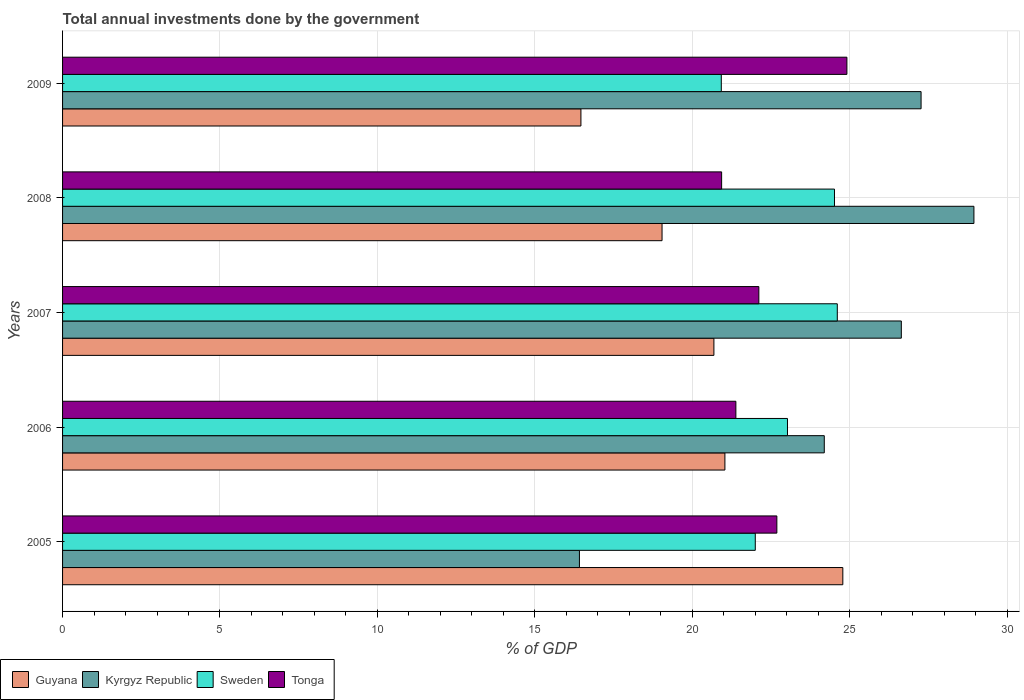How many different coloured bars are there?
Give a very brief answer. 4. Are the number of bars per tick equal to the number of legend labels?
Ensure brevity in your answer.  Yes. How many bars are there on the 5th tick from the top?
Your response must be concise. 4. How many bars are there on the 4th tick from the bottom?
Ensure brevity in your answer.  4. In how many cases, is the number of bars for a given year not equal to the number of legend labels?
Make the answer very short. 0. What is the total annual investments done by the government in Tonga in 2008?
Offer a terse response. 20.93. Across all years, what is the maximum total annual investments done by the government in Sweden?
Provide a short and direct response. 24.61. Across all years, what is the minimum total annual investments done by the government in Guyana?
Offer a very short reply. 16.47. In which year was the total annual investments done by the government in Guyana minimum?
Offer a terse response. 2009. What is the total total annual investments done by the government in Kyrgyz Republic in the graph?
Provide a short and direct response. 123.48. What is the difference between the total annual investments done by the government in Kyrgyz Republic in 2005 and that in 2008?
Make the answer very short. -12.53. What is the difference between the total annual investments done by the government in Guyana in 2009 and the total annual investments done by the government in Sweden in 2007?
Give a very brief answer. -8.14. What is the average total annual investments done by the government in Guyana per year?
Offer a terse response. 20.4. In the year 2005, what is the difference between the total annual investments done by the government in Tonga and total annual investments done by the government in Sweden?
Your answer should be compact. 0.69. In how many years, is the total annual investments done by the government in Tonga greater than 10 %?
Your response must be concise. 5. What is the ratio of the total annual investments done by the government in Kyrgyz Republic in 2007 to that in 2008?
Offer a terse response. 0.92. Is the difference between the total annual investments done by the government in Tonga in 2005 and 2006 greater than the difference between the total annual investments done by the government in Sweden in 2005 and 2006?
Keep it short and to the point. Yes. What is the difference between the highest and the second highest total annual investments done by the government in Tonga?
Your answer should be compact. 2.23. What is the difference between the highest and the lowest total annual investments done by the government in Guyana?
Make the answer very short. 8.32. Is the sum of the total annual investments done by the government in Sweden in 2005 and 2007 greater than the maximum total annual investments done by the government in Guyana across all years?
Give a very brief answer. Yes. Is it the case that in every year, the sum of the total annual investments done by the government in Guyana and total annual investments done by the government in Tonga is greater than the sum of total annual investments done by the government in Kyrgyz Republic and total annual investments done by the government in Sweden?
Make the answer very short. No. What does the 1st bar from the top in 2007 represents?
Ensure brevity in your answer.  Tonga. Is it the case that in every year, the sum of the total annual investments done by the government in Guyana and total annual investments done by the government in Kyrgyz Republic is greater than the total annual investments done by the government in Tonga?
Your answer should be compact. Yes. Are all the bars in the graph horizontal?
Offer a very short reply. Yes. How many years are there in the graph?
Provide a succinct answer. 5. Does the graph contain any zero values?
Provide a short and direct response. No. Where does the legend appear in the graph?
Ensure brevity in your answer.  Bottom left. How many legend labels are there?
Your answer should be very brief. 4. How are the legend labels stacked?
Give a very brief answer. Horizontal. What is the title of the graph?
Make the answer very short. Total annual investments done by the government. Does "Latin America(developing only)" appear as one of the legend labels in the graph?
Make the answer very short. No. What is the label or title of the X-axis?
Ensure brevity in your answer.  % of GDP. What is the label or title of the Y-axis?
Your response must be concise. Years. What is the % of GDP in Guyana in 2005?
Offer a very short reply. 24.78. What is the % of GDP of Kyrgyz Republic in 2005?
Give a very brief answer. 16.42. What is the % of GDP in Sweden in 2005?
Give a very brief answer. 22. What is the % of GDP in Tonga in 2005?
Keep it short and to the point. 22.69. What is the % of GDP of Guyana in 2006?
Your answer should be compact. 21.04. What is the % of GDP in Kyrgyz Republic in 2006?
Your answer should be very brief. 24.2. What is the % of GDP in Sweden in 2006?
Make the answer very short. 23.03. What is the % of GDP of Tonga in 2006?
Keep it short and to the point. 21.39. What is the % of GDP in Guyana in 2007?
Give a very brief answer. 20.69. What is the % of GDP of Kyrgyz Republic in 2007?
Offer a very short reply. 26.64. What is the % of GDP in Sweden in 2007?
Your response must be concise. 24.61. What is the % of GDP of Tonga in 2007?
Your answer should be compact. 22.12. What is the % of GDP in Guyana in 2008?
Ensure brevity in your answer.  19.04. What is the % of GDP of Kyrgyz Republic in 2008?
Provide a succinct answer. 28.95. What is the % of GDP of Sweden in 2008?
Make the answer very short. 24.52. What is the % of GDP in Tonga in 2008?
Your answer should be compact. 20.93. What is the % of GDP in Guyana in 2009?
Your answer should be very brief. 16.47. What is the % of GDP of Kyrgyz Republic in 2009?
Give a very brief answer. 27.27. What is the % of GDP in Sweden in 2009?
Offer a very short reply. 20.92. What is the % of GDP in Tonga in 2009?
Offer a very short reply. 24.91. Across all years, what is the maximum % of GDP in Guyana?
Provide a succinct answer. 24.78. Across all years, what is the maximum % of GDP in Kyrgyz Republic?
Give a very brief answer. 28.95. Across all years, what is the maximum % of GDP of Sweden?
Your answer should be very brief. 24.61. Across all years, what is the maximum % of GDP in Tonga?
Keep it short and to the point. 24.91. Across all years, what is the minimum % of GDP in Guyana?
Ensure brevity in your answer.  16.47. Across all years, what is the minimum % of GDP in Kyrgyz Republic?
Offer a very short reply. 16.42. Across all years, what is the minimum % of GDP in Sweden?
Keep it short and to the point. 20.92. Across all years, what is the minimum % of GDP in Tonga?
Give a very brief answer. 20.93. What is the total % of GDP in Guyana in the graph?
Provide a succinct answer. 102.02. What is the total % of GDP in Kyrgyz Republic in the graph?
Keep it short and to the point. 123.48. What is the total % of GDP in Sweden in the graph?
Your answer should be very brief. 115.08. What is the total % of GDP in Tonga in the graph?
Provide a succinct answer. 112.04. What is the difference between the % of GDP of Guyana in 2005 and that in 2006?
Give a very brief answer. 3.75. What is the difference between the % of GDP of Kyrgyz Republic in 2005 and that in 2006?
Provide a succinct answer. -7.78. What is the difference between the % of GDP in Sweden in 2005 and that in 2006?
Provide a succinct answer. -1.02. What is the difference between the % of GDP of Tonga in 2005 and that in 2006?
Provide a short and direct response. 1.3. What is the difference between the % of GDP of Guyana in 2005 and that in 2007?
Your answer should be very brief. 4.1. What is the difference between the % of GDP in Kyrgyz Republic in 2005 and that in 2007?
Offer a terse response. -10.22. What is the difference between the % of GDP of Sweden in 2005 and that in 2007?
Offer a terse response. -2.6. What is the difference between the % of GDP of Tonga in 2005 and that in 2007?
Keep it short and to the point. 0.57. What is the difference between the % of GDP of Guyana in 2005 and that in 2008?
Your answer should be compact. 5.74. What is the difference between the % of GDP in Kyrgyz Republic in 2005 and that in 2008?
Make the answer very short. -12.53. What is the difference between the % of GDP of Sweden in 2005 and that in 2008?
Keep it short and to the point. -2.52. What is the difference between the % of GDP of Tonga in 2005 and that in 2008?
Your answer should be compact. 1.75. What is the difference between the % of GDP in Guyana in 2005 and that in 2009?
Provide a short and direct response. 8.32. What is the difference between the % of GDP of Kyrgyz Republic in 2005 and that in 2009?
Provide a short and direct response. -10.85. What is the difference between the % of GDP in Sweden in 2005 and that in 2009?
Ensure brevity in your answer.  1.08. What is the difference between the % of GDP in Tonga in 2005 and that in 2009?
Keep it short and to the point. -2.23. What is the difference between the % of GDP in Guyana in 2006 and that in 2007?
Offer a terse response. 0.35. What is the difference between the % of GDP in Kyrgyz Republic in 2006 and that in 2007?
Keep it short and to the point. -2.45. What is the difference between the % of GDP of Sweden in 2006 and that in 2007?
Make the answer very short. -1.58. What is the difference between the % of GDP in Tonga in 2006 and that in 2007?
Your answer should be compact. -0.73. What is the difference between the % of GDP in Guyana in 2006 and that in 2008?
Provide a short and direct response. 2. What is the difference between the % of GDP of Kyrgyz Republic in 2006 and that in 2008?
Give a very brief answer. -4.75. What is the difference between the % of GDP of Sweden in 2006 and that in 2008?
Your answer should be compact. -1.49. What is the difference between the % of GDP of Tonga in 2006 and that in 2008?
Ensure brevity in your answer.  0.45. What is the difference between the % of GDP of Guyana in 2006 and that in 2009?
Provide a succinct answer. 4.57. What is the difference between the % of GDP in Kyrgyz Republic in 2006 and that in 2009?
Offer a very short reply. -3.07. What is the difference between the % of GDP of Sweden in 2006 and that in 2009?
Your response must be concise. 2.1. What is the difference between the % of GDP in Tonga in 2006 and that in 2009?
Keep it short and to the point. -3.53. What is the difference between the % of GDP in Guyana in 2007 and that in 2008?
Provide a short and direct response. 1.65. What is the difference between the % of GDP of Kyrgyz Republic in 2007 and that in 2008?
Ensure brevity in your answer.  -2.31. What is the difference between the % of GDP of Sweden in 2007 and that in 2008?
Give a very brief answer. 0.09. What is the difference between the % of GDP of Tonga in 2007 and that in 2008?
Ensure brevity in your answer.  1.18. What is the difference between the % of GDP of Guyana in 2007 and that in 2009?
Offer a very short reply. 4.22. What is the difference between the % of GDP in Kyrgyz Republic in 2007 and that in 2009?
Make the answer very short. -0.63. What is the difference between the % of GDP in Sweden in 2007 and that in 2009?
Your answer should be very brief. 3.68. What is the difference between the % of GDP in Tonga in 2007 and that in 2009?
Make the answer very short. -2.8. What is the difference between the % of GDP of Guyana in 2008 and that in 2009?
Offer a terse response. 2.58. What is the difference between the % of GDP in Kyrgyz Republic in 2008 and that in 2009?
Keep it short and to the point. 1.68. What is the difference between the % of GDP of Sweden in 2008 and that in 2009?
Make the answer very short. 3.6. What is the difference between the % of GDP of Tonga in 2008 and that in 2009?
Provide a short and direct response. -3.98. What is the difference between the % of GDP of Guyana in 2005 and the % of GDP of Kyrgyz Republic in 2006?
Ensure brevity in your answer.  0.59. What is the difference between the % of GDP in Guyana in 2005 and the % of GDP in Sweden in 2006?
Your answer should be very brief. 1.76. What is the difference between the % of GDP in Guyana in 2005 and the % of GDP in Tonga in 2006?
Offer a terse response. 3.4. What is the difference between the % of GDP in Kyrgyz Republic in 2005 and the % of GDP in Sweden in 2006?
Offer a terse response. -6.61. What is the difference between the % of GDP in Kyrgyz Republic in 2005 and the % of GDP in Tonga in 2006?
Your answer should be very brief. -4.97. What is the difference between the % of GDP of Sweden in 2005 and the % of GDP of Tonga in 2006?
Your answer should be compact. 0.62. What is the difference between the % of GDP of Guyana in 2005 and the % of GDP of Kyrgyz Republic in 2007?
Your answer should be compact. -1.86. What is the difference between the % of GDP of Guyana in 2005 and the % of GDP of Sweden in 2007?
Offer a very short reply. 0.18. What is the difference between the % of GDP in Guyana in 2005 and the % of GDP in Tonga in 2007?
Provide a short and direct response. 2.67. What is the difference between the % of GDP of Kyrgyz Republic in 2005 and the % of GDP of Sweden in 2007?
Offer a very short reply. -8.19. What is the difference between the % of GDP in Kyrgyz Republic in 2005 and the % of GDP in Tonga in 2007?
Your answer should be compact. -5.7. What is the difference between the % of GDP of Sweden in 2005 and the % of GDP of Tonga in 2007?
Keep it short and to the point. -0.11. What is the difference between the % of GDP of Guyana in 2005 and the % of GDP of Kyrgyz Republic in 2008?
Your response must be concise. -4.16. What is the difference between the % of GDP of Guyana in 2005 and the % of GDP of Sweden in 2008?
Offer a very short reply. 0.27. What is the difference between the % of GDP of Guyana in 2005 and the % of GDP of Tonga in 2008?
Your answer should be compact. 3.85. What is the difference between the % of GDP of Kyrgyz Republic in 2005 and the % of GDP of Sweden in 2008?
Make the answer very short. -8.1. What is the difference between the % of GDP in Kyrgyz Republic in 2005 and the % of GDP in Tonga in 2008?
Ensure brevity in your answer.  -4.52. What is the difference between the % of GDP in Sweden in 2005 and the % of GDP in Tonga in 2008?
Provide a succinct answer. 1.07. What is the difference between the % of GDP of Guyana in 2005 and the % of GDP of Kyrgyz Republic in 2009?
Your response must be concise. -2.49. What is the difference between the % of GDP of Guyana in 2005 and the % of GDP of Sweden in 2009?
Offer a very short reply. 3.86. What is the difference between the % of GDP in Guyana in 2005 and the % of GDP in Tonga in 2009?
Make the answer very short. -0.13. What is the difference between the % of GDP in Kyrgyz Republic in 2005 and the % of GDP in Sweden in 2009?
Ensure brevity in your answer.  -4.51. What is the difference between the % of GDP of Kyrgyz Republic in 2005 and the % of GDP of Tonga in 2009?
Provide a succinct answer. -8.5. What is the difference between the % of GDP in Sweden in 2005 and the % of GDP in Tonga in 2009?
Ensure brevity in your answer.  -2.91. What is the difference between the % of GDP in Guyana in 2006 and the % of GDP in Kyrgyz Republic in 2007?
Your answer should be very brief. -5.6. What is the difference between the % of GDP in Guyana in 2006 and the % of GDP in Sweden in 2007?
Your answer should be very brief. -3.57. What is the difference between the % of GDP of Guyana in 2006 and the % of GDP of Tonga in 2007?
Ensure brevity in your answer.  -1.08. What is the difference between the % of GDP of Kyrgyz Republic in 2006 and the % of GDP of Sweden in 2007?
Provide a short and direct response. -0.41. What is the difference between the % of GDP of Kyrgyz Republic in 2006 and the % of GDP of Tonga in 2007?
Ensure brevity in your answer.  2.08. What is the difference between the % of GDP in Sweden in 2006 and the % of GDP in Tonga in 2007?
Ensure brevity in your answer.  0.91. What is the difference between the % of GDP in Guyana in 2006 and the % of GDP in Kyrgyz Republic in 2008?
Ensure brevity in your answer.  -7.91. What is the difference between the % of GDP in Guyana in 2006 and the % of GDP in Sweden in 2008?
Provide a short and direct response. -3.48. What is the difference between the % of GDP of Guyana in 2006 and the % of GDP of Tonga in 2008?
Your response must be concise. 0.1. What is the difference between the % of GDP in Kyrgyz Republic in 2006 and the % of GDP in Sweden in 2008?
Keep it short and to the point. -0.32. What is the difference between the % of GDP of Kyrgyz Republic in 2006 and the % of GDP of Tonga in 2008?
Provide a short and direct response. 3.26. What is the difference between the % of GDP of Sweden in 2006 and the % of GDP of Tonga in 2008?
Offer a terse response. 2.09. What is the difference between the % of GDP of Guyana in 2006 and the % of GDP of Kyrgyz Republic in 2009?
Keep it short and to the point. -6.23. What is the difference between the % of GDP of Guyana in 2006 and the % of GDP of Sweden in 2009?
Offer a terse response. 0.12. What is the difference between the % of GDP in Guyana in 2006 and the % of GDP in Tonga in 2009?
Your answer should be compact. -3.87. What is the difference between the % of GDP of Kyrgyz Republic in 2006 and the % of GDP of Sweden in 2009?
Ensure brevity in your answer.  3.27. What is the difference between the % of GDP of Kyrgyz Republic in 2006 and the % of GDP of Tonga in 2009?
Provide a succinct answer. -0.72. What is the difference between the % of GDP of Sweden in 2006 and the % of GDP of Tonga in 2009?
Keep it short and to the point. -1.89. What is the difference between the % of GDP in Guyana in 2007 and the % of GDP in Kyrgyz Republic in 2008?
Your response must be concise. -8.26. What is the difference between the % of GDP of Guyana in 2007 and the % of GDP of Sweden in 2008?
Keep it short and to the point. -3.83. What is the difference between the % of GDP of Guyana in 2007 and the % of GDP of Tonga in 2008?
Your answer should be compact. -0.24. What is the difference between the % of GDP in Kyrgyz Republic in 2007 and the % of GDP in Sweden in 2008?
Provide a short and direct response. 2.12. What is the difference between the % of GDP in Kyrgyz Republic in 2007 and the % of GDP in Tonga in 2008?
Provide a short and direct response. 5.71. What is the difference between the % of GDP of Sweden in 2007 and the % of GDP of Tonga in 2008?
Your answer should be compact. 3.67. What is the difference between the % of GDP of Guyana in 2007 and the % of GDP of Kyrgyz Republic in 2009?
Provide a succinct answer. -6.58. What is the difference between the % of GDP of Guyana in 2007 and the % of GDP of Sweden in 2009?
Ensure brevity in your answer.  -0.23. What is the difference between the % of GDP of Guyana in 2007 and the % of GDP of Tonga in 2009?
Ensure brevity in your answer.  -4.22. What is the difference between the % of GDP in Kyrgyz Republic in 2007 and the % of GDP in Sweden in 2009?
Give a very brief answer. 5.72. What is the difference between the % of GDP in Kyrgyz Republic in 2007 and the % of GDP in Tonga in 2009?
Your response must be concise. 1.73. What is the difference between the % of GDP of Sweden in 2007 and the % of GDP of Tonga in 2009?
Your answer should be compact. -0.31. What is the difference between the % of GDP of Guyana in 2008 and the % of GDP of Kyrgyz Republic in 2009?
Make the answer very short. -8.23. What is the difference between the % of GDP in Guyana in 2008 and the % of GDP in Sweden in 2009?
Ensure brevity in your answer.  -1.88. What is the difference between the % of GDP in Guyana in 2008 and the % of GDP in Tonga in 2009?
Give a very brief answer. -5.87. What is the difference between the % of GDP in Kyrgyz Republic in 2008 and the % of GDP in Sweden in 2009?
Provide a short and direct response. 8.02. What is the difference between the % of GDP in Kyrgyz Republic in 2008 and the % of GDP in Tonga in 2009?
Your answer should be very brief. 4.03. What is the difference between the % of GDP of Sweden in 2008 and the % of GDP of Tonga in 2009?
Your answer should be very brief. -0.39. What is the average % of GDP of Guyana per year?
Provide a short and direct response. 20.4. What is the average % of GDP of Kyrgyz Republic per year?
Give a very brief answer. 24.7. What is the average % of GDP in Sweden per year?
Offer a very short reply. 23.02. What is the average % of GDP in Tonga per year?
Offer a terse response. 22.41. In the year 2005, what is the difference between the % of GDP of Guyana and % of GDP of Kyrgyz Republic?
Offer a terse response. 8.37. In the year 2005, what is the difference between the % of GDP of Guyana and % of GDP of Sweden?
Your answer should be compact. 2.78. In the year 2005, what is the difference between the % of GDP in Guyana and % of GDP in Tonga?
Offer a terse response. 2.1. In the year 2005, what is the difference between the % of GDP of Kyrgyz Republic and % of GDP of Sweden?
Your answer should be very brief. -5.59. In the year 2005, what is the difference between the % of GDP of Kyrgyz Republic and % of GDP of Tonga?
Keep it short and to the point. -6.27. In the year 2005, what is the difference between the % of GDP of Sweden and % of GDP of Tonga?
Ensure brevity in your answer.  -0.69. In the year 2006, what is the difference between the % of GDP in Guyana and % of GDP in Kyrgyz Republic?
Your response must be concise. -3.16. In the year 2006, what is the difference between the % of GDP in Guyana and % of GDP in Sweden?
Your answer should be very brief. -1.99. In the year 2006, what is the difference between the % of GDP in Guyana and % of GDP in Tonga?
Give a very brief answer. -0.35. In the year 2006, what is the difference between the % of GDP in Kyrgyz Republic and % of GDP in Sweden?
Keep it short and to the point. 1.17. In the year 2006, what is the difference between the % of GDP in Kyrgyz Republic and % of GDP in Tonga?
Provide a succinct answer. 2.81. In the year 2006, what is the difference between the % of GDP of Sweden and % of GDP of Tonga?
Your response must be concise. 1.64. In the year 2007, what is the difference between the % of GDP in Guyana and % of GDP in Kyrgyz Republic?
Give a very brief answer. -5.95. In the year 2007, what is the difference between the % of GDP in Guyana and % of GDP in Sweden?
Your answer should be compact. -3.92. In the year 2007, what is the difference between the % of GDP of Guyana and % of GDP of Tonga?
Offer a very short reply. -1.43. In the year 2007, what is the difference between the % of GDP of Kyrgyz Republic and % of GDP of Sweden?
Ensure brevity in your answer.  2.03. In the year 2007, what is the difference between the % of GDP in Kyrgyz Republic and % of GDP in Tonga?
Ensure brevity in your answer.  4.53. In the year 2007, what is the difference between the % of GDP of Sweden and % of GDP of Tonga?
Offer a very short reply. 2.49. In the year 2008, what is the difference between the % of GDP of Guyana and % of GDP of Kyrgyz Republic?
Provide a succinct answer. -9.91. In the year 2008, what is the difference between the % of GDP of Guyana and % of GDP of Sweden?
Your answer should be compact. -5.48. In the year 2008, what is the difference between the % of GDP in Guyana and % of GDP in Tonga?
Offer a very short reply. -1.89. In the year 2008, what is the difference between the % of GDP of Kyrgyz Republic and % of GDP of Sweden?
Make the answer very short. 4.43. In the year 2008, what is the difference between the % of GDP in Kyrgyz Republic and % of GDP in Tonga?
Give a very brief answer. 8.01. In the year 2008, what is the difference between the % of GDP of Sweden and % of GDP of Tonga?
Your answer should be compact. 3.58. In the year 2009, what is the difference between the % of GDP of Guyana and % of GDP of Kyrgyz Republic?
Your answer should be very brief. -10.8. In the year 2009, what is the difference between the % of GDP of Guyana and % of GDP of Sweden?
Provide a succinct answer. -4.46. In the year 2009, what is the difference between the % of GDP in Guyana and % of GDP in Tonga?
Your answer should be very brief. -8.45. In the year 2009, what is the difference between the % of GDP of Kyrgyz Republic and % of GDP of Sweden?
Your answer should be compact. 6.35. In the year 2009, what is the difference between the % of GDP of Kyrgyz Republic and % of GDP of Tonga?
Keep it short and to the point. 2.36. In the year 2009, what is the difference between the % of GDP in Sweden and % of GDP in Tonga?
Your answer should be compact. -3.99. What is the ratio of the % of GDP in Guyana in 2005 to that in 2006?
Your answer should be very brief. 1.18. What is the ratio of the % of GDP of Kyrgyz Republic in 2005 to that in 2006?
Ensure brevity in your answer.  0.68. What is the ratio of the % of GDP in Sweden in 2005 to that in 2006?
Provide a succinct answer. 0.96. What is the ratio of the % of GDP in Tonga in 2005 to that in 2006?
Offer a very short reply. 1.06. What is the ratio of the % of GDP in Guyana in 2005 to that in 2007?
Your response must be concise. 1.2. What is the ratio of the % of GDP of Kyrgyz Republic in 2005 to that in 2007?
Your response must be concise. 0.62. What is the ratio of the % of GDP in Sweden in 2005 to that in 2007?
Offer a terse response. 0.89. What is the ratio of the % of GDP in Tonga in 2005 to that in 2007?
Ensure brevity in your answer.  1.03. What is the ratio of the % of GDP in Guyana in 2005 to that in 2008?
Keep it short and to the point. 1.3. What is the ratio of the % of GDP of Kyrgyz Republic in 2005 to that in 2008?
Make the answer very short. 0.57. What is the ratio of the % of GDP of Sweden in 2005 to that in 2008?
Offer a very short reply. 0.9. What is the ratio of the % of GDP of Tonga in 2005 to that in 2008?
Your response must be concise. 1.08. What is the ratio of the % of GDP of Guyana in 2005 to that in 2009?
Offer a very short reply. 1.51. What is the ratio of the % of GDP of Kyrgyz Republic in 2005 to that in 2009?
Provide a short and direct response. 0.6. What is the ratio of the % of GDP of Sweden in 2005 to that in 2009?
Give a very brief answer. 1.05. What is the ratio of the % of GDP in Tonga in 2005 to that in 2009?
Your answer should be very brief. 0.91. What is the ratio of the % of GDP of Guyana in 2006 to that in 2007?
Ensure brevity in your answer.  1.02. What is the ratio of the % of GDP of Kyrgyz Republic in 2006 to that in 2007?
Keep it short and to the point. 0.91. What is the ratio of the % of GDP in Sweden in 2006 to that in 2007?
Your answer should be compact. 0.94. What is the ratio of the % of GDP of Guyana in 2006 to that in 2008?
Ensure brevity in your answer.  1.1. What is the ratio of the % of GDP in Kyrgyz Republic in 2006 to that in 2008?
Your response must be concise. 0.84. What is the ratio of the % of GDP in Sweden in 2006 to that in 2008?
Provide a succinct answer. 0.94. What is the ratio of the % of GDP of Tonga in 2006 to that in 2008?
Provide a succinct answer. 1.02. What is the ratio of the % of GDP of Guyana in 2006 to that in 2009?
Your answer should be compact. 1.28. What is the ratio of the % of GDP in Kyrgyz Republic in 2006 to that in 2009?
Your answer should be very brief. 0.89. What is the ratio of the % of GDP of Sweden in 2006 to that in 2009?
Ensure brevity in your answer.  1.1. What is the ratio of the % of GDP of Tonga in 2006 to that in 2009?
Your answer should be compact. 0.86. What is the ratio of the % of GDP of Guyana in 2007 to that in 2008?
Keep it short and to the point. 1.09. What is the ratio of the % of GDP in Kyrgyz Republic in 2007 to that in 2008?
Keep it short and to the point. 0.92. What is the ratio of the % of GDP of Sweden in 2007 to that in 2008?
Offer a very short reply. 1. What is the ratio of the % of GDP of Tonga in 2007 to that in 2008?
Your answer should be compact. 1.06. What is the ratio of the % of GDP of Guyana in 2007 to that in 2009?
Your answer should be very brief. 1.26. What is the ratio of the % of GDP in Sweden in 2007 to that in 2009?
Provide a short and direct response. 1.18. What is the ratio of the % of GDP of Tonga in 2007 to that in 2009?
Provide a short and direct response. 0.89. What is the ratio of the % of GDP of Guyana in 2008 to that in 2009?
Offer a terse response. 1.16. What is the ratio of the % of GDP in Kyrgyz Republic in 2008 to that in 2009?
Your answer should be very brief. 1.06. What is the ratio of the % of GDP of Sweden in 2008 to that in 2009?
Ensure brevity in your answer.  1.17. What is the ratio of the % of GDP in Tonga in 2008 to that in 2009?
Ensure brevity in your answer.  0.84. What is the difference between the highest and the second highest % of GDP of Guyana?
Offer a terse response. 3.75. What is the difference between the highest and the second highest % of GDP in Kyrgyz Republic?
Your answer should be compact. 1.68. What is the difference between the highest and the second highest % of GDP of Sweden?
Offer a terse response. 0.09. What is the difference between the highest and the second highest % of GDP in Tonga?
Provide a succinct answer. 2.23. What is the difference between the highest and the lowest % of GDP of Guyana?
Provide a succinct answer. 8.32. What is the difference between the highest and the lowest % of GDP in Kyrgyz Republic?
Offer a terse response. 12.53. What is the difference between the highest and the lowest % of GDP of Sweden?
Provide a short and direct response. 3.68. What is the difference between the highest and the lowest % of GDP of Tonga?
Your answer should be very brief. 3.98. 